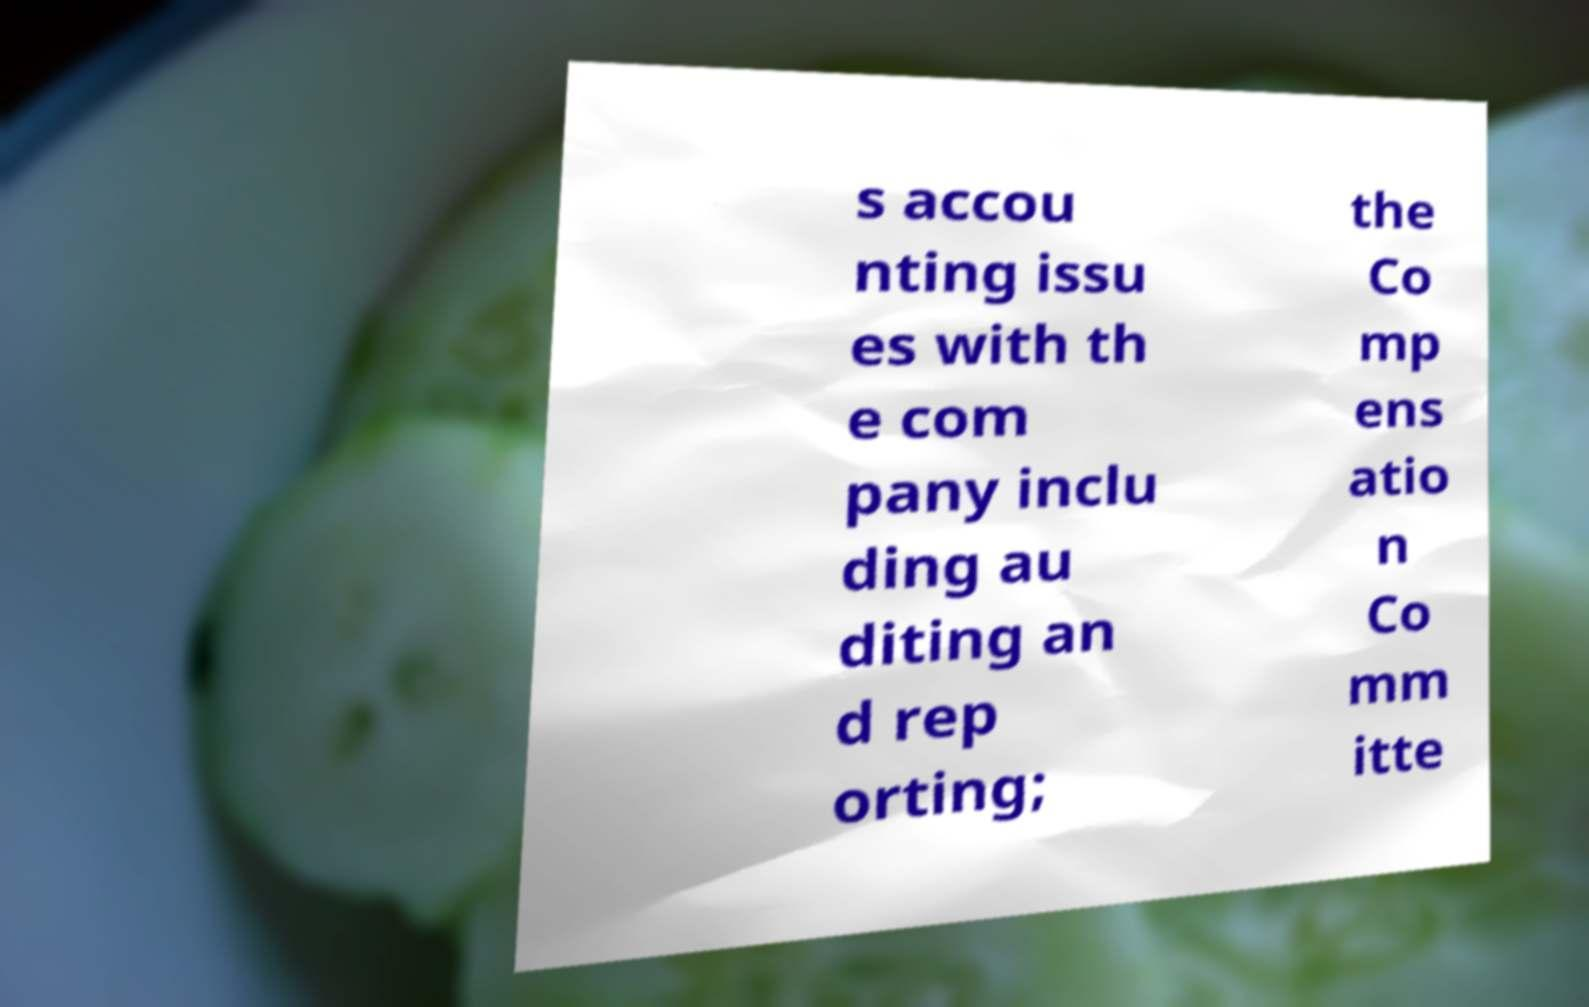For documentation purposes, I need the text within this image transcribed. Could you provide that? s accou nting issu es with th e com pany inclu ding au diting an d rep orting; the Co mp ens atio n Co mm itte 